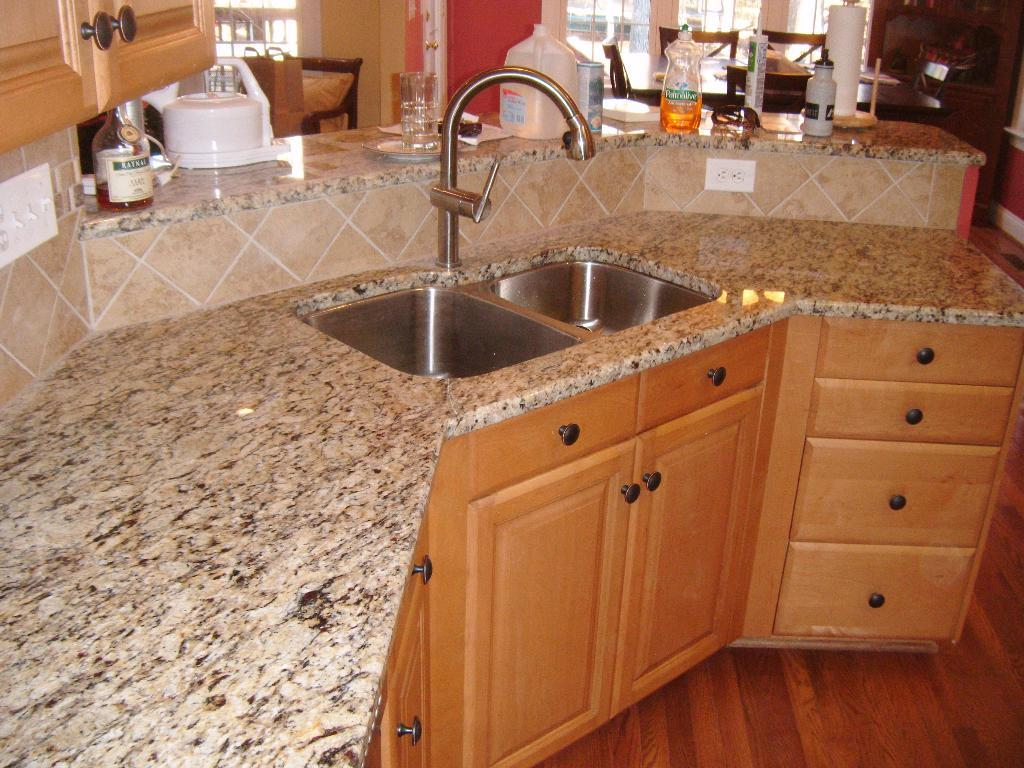What type of furniture is present in the image? There is a chair in the image. What type of storage is available in the image? There is a cupboard and drawers in the image. What can be found on the counter in the image? There are bottles and glasses on the counter in the image. What type of appliance is present in the image? There is a sink in the image. What is the purpose of the window in the image? The window provides natural light and a view of the outside. What type of wilderness can be seen through the window in the image? There is no wilderness visible through the window in the image; it is a room with a counter, sink, cupboard, drawers, bottles, glasses, and a chair. Can you tell me how many times the chair kicks the bottle in the image? There is no interaction between the chair and the bottle in the image; they are separate objects. 